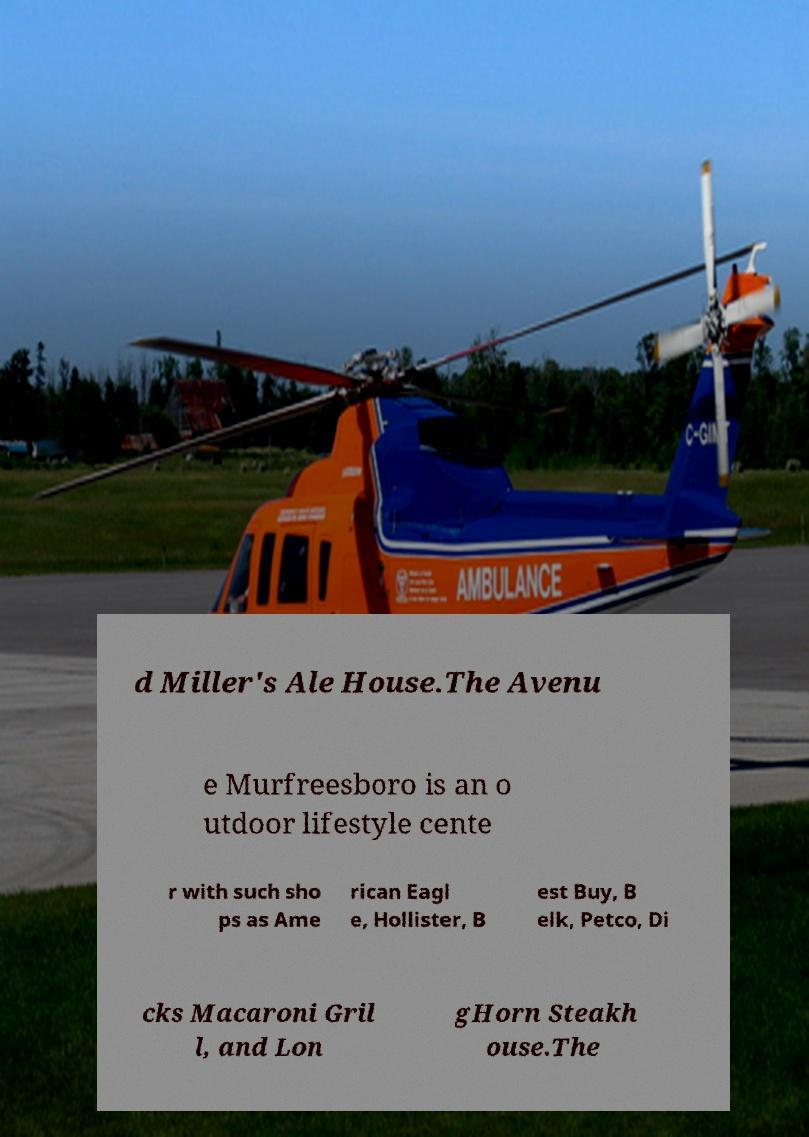Could you assist in decoding the text presented in this image and type it out clearly? d Miller's Ale House.The Avenu e Murfreesboro is an o utdoor lifestyle cente r with such sho ps as Ame rican Eagl e, Hollister, B est Buy, B elk, Petco, Di cks Macaroni Gril l, and Lon gHorn Steakh ouse.The 